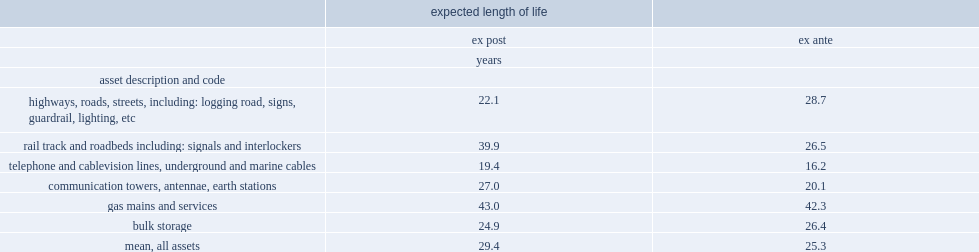How many years are the ex post estimates for the long-lived assets? 29.4. How many years are the ex ante estimates for the long-lived assets? 25.3. 